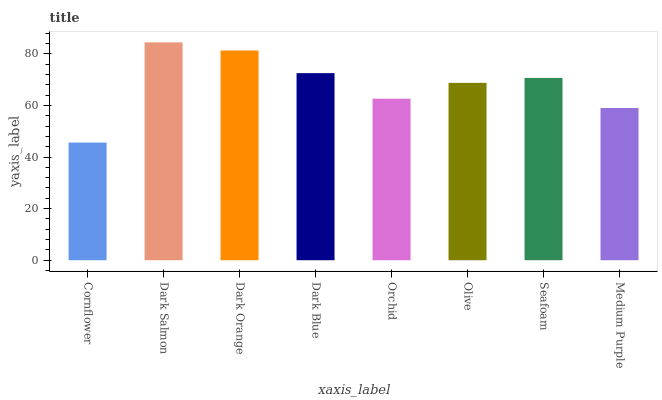Is Cornflower the minimum?
Answer yes or no. Yes. Is Dark Salmon the maximum?
Answer yes or no. Yes. Is Dark Orange the minimum?
Answer yes or no. No. Is Dark Orange the maximum?
Answer yes or no. No. Is Dark Salmon greater than Dark Orange?
Answer yes or no. Yes. Is Dark Orange less than Dark Salmon?
Answer yes or no. Yes. Is Dark Orange greater than Dark Salmon?
Answer yes or no. No. Is Dark Salmon less than Dark Orange?
Answer yes or no. No. Is Seafoam the high median?
Answer yes or no. Yes. Is Olive the low median?
Answer yes or no. Yes. Is Dark Orange the high median?
Answer yes or no. No. Is Medium Purple the low median?
Answer yes or no. No. 